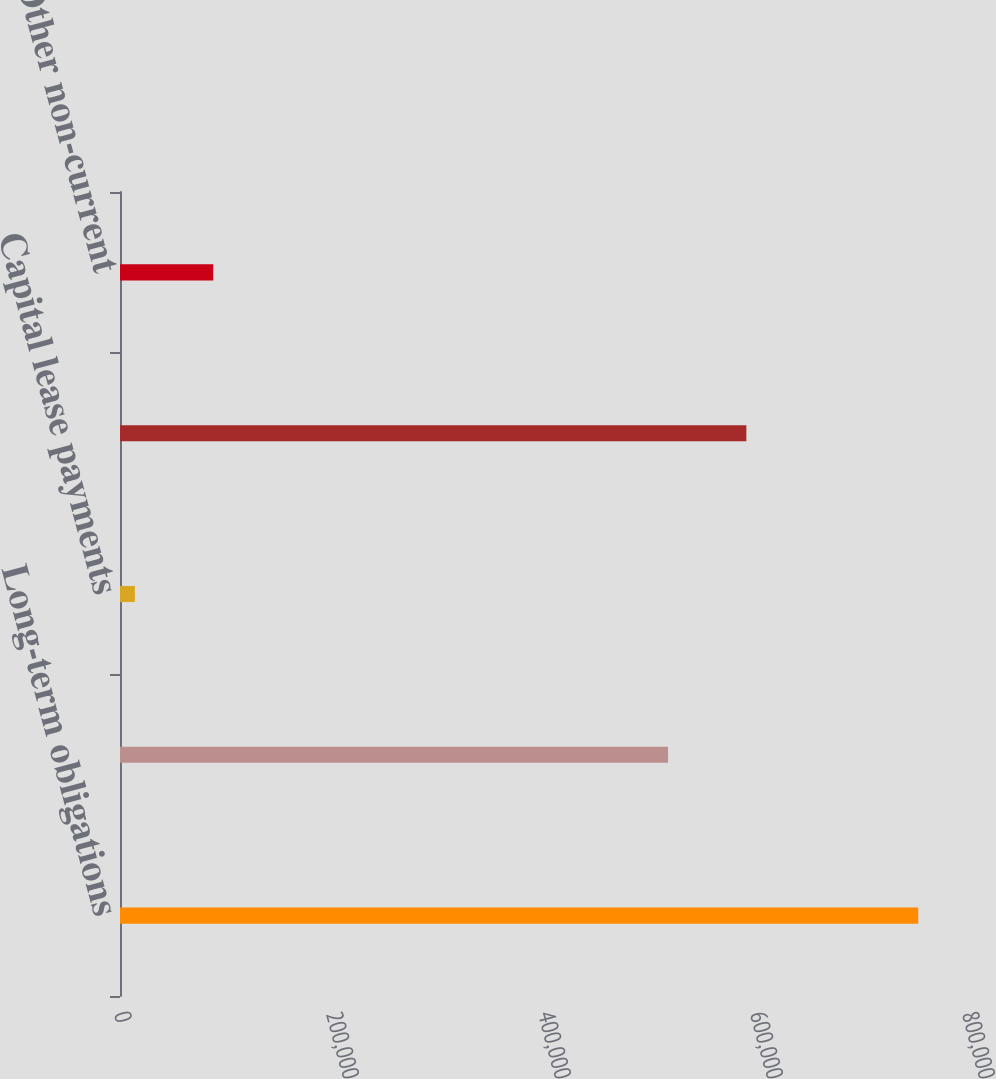Convert chart. <chart><loc_0><loc_0><loc_500><loc_500><bar_chart><fcel>Long-term obligations<fcel>Cash interest expense<fcel>Capital lease payments<fcel>Operating lease payments(11)<fcel>Other non-current<nl><fcel>753045<fcel>517000<fcel>14049<fcel>590900<fcel>87948.6<nl></chart> 